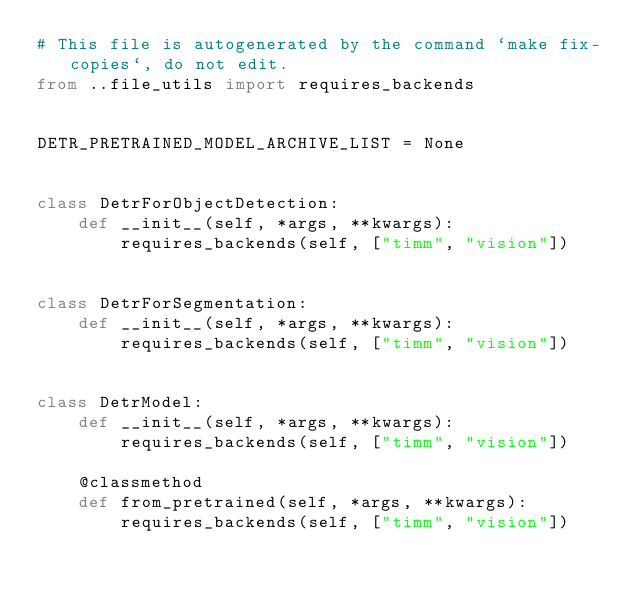<code> <loc_0><loc_0><loc_500><loc_500><_Python_># This file is autogenerated by the command `make fix-copies`, do not edit.
from ..file_utils import requires_backends


DETR_PRETRAINED_MODEL_ARCHIVE_LIST = None


class DetrForObjectDetection:
    def __init__(self, *args, **kwargs):
        requires_backends(self, ["timm", "vision"])


class DetrForSegmentation:
    def __init__(self, *args, **kwargs):
        requires_backends(self, ["timm", "vision"])


class DetrModel:
    def __init__(self, *args, **kwargs):
        requires_backends(self, ["timm", "vision"])

    @classmethod
    def from_pretrained(self, *args, **kwargs):
        requires_backends(self, ["timm", "vision"])
</code> 